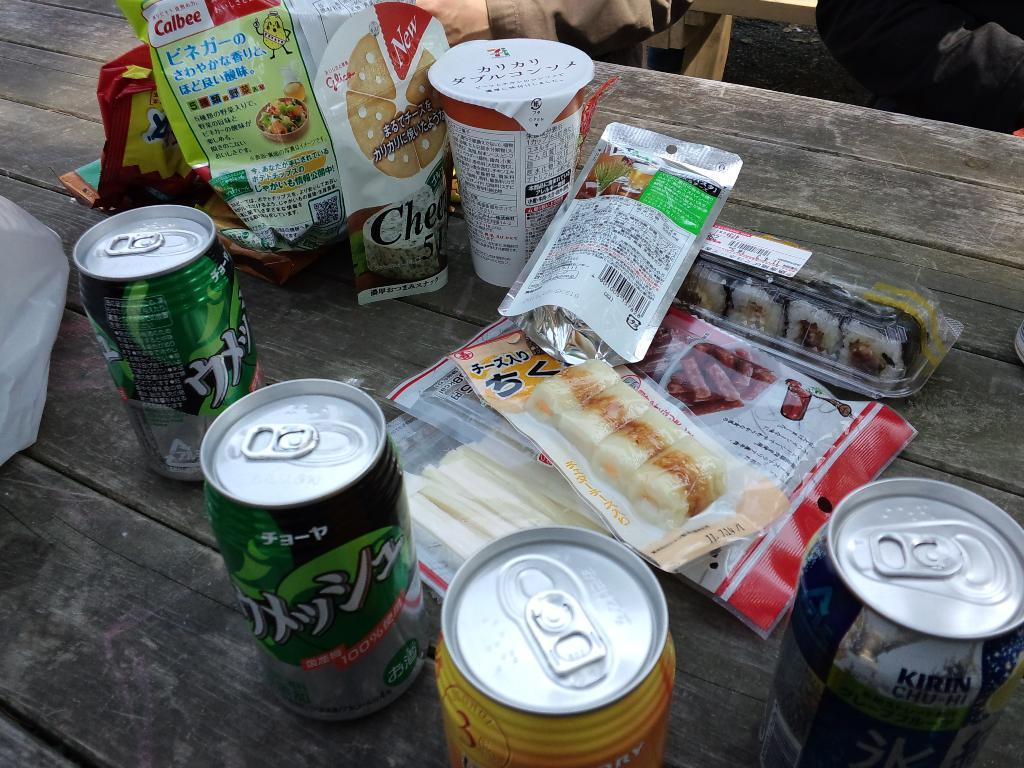<image>
Offer a succinct explanation of the picture presented. A picnic table has a bunch of snacks like sushi and cans of soda that say Kirin. 